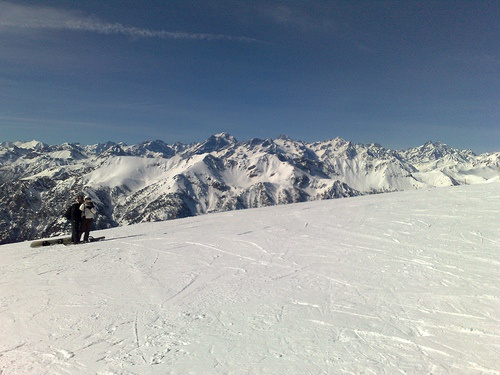Describe the objects in this image and their specific colors. I can see people in gray and black tones, people in gray, black, maroon, and darkgray tones, and snowboard in gray, black, and darkgray tones in this image. 